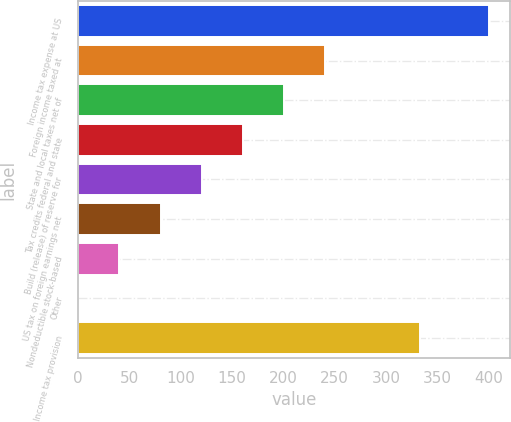Convert chart. <chart><loc_0><loc_0><loc_500><loc_500><bar_chart><fcel>Income tax expense at US<fcel>Foreign income taxed at<fcel>State and local taxes net of<fcel>Tax credits federal and state<fcel>Build (release) of reserve for<fcel>US tax on foreign earnings net<fcel>Nondeductible stock-based<fcel>Other<fcel>Income tax provision<nl><fcel>400.4<fcel>240.4<fcel>200.4<fcel>160.4<fcel>120.4<fcel>80.4<fcel>40.4<fcel>0.4<fcel>332.9<nl></chart> 